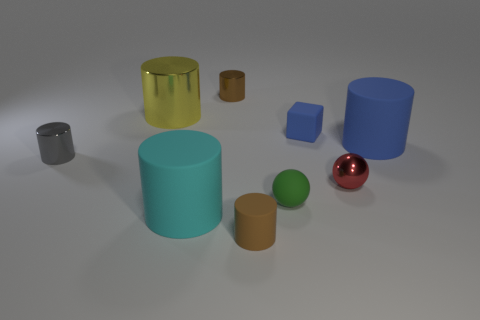There is a yellow object; does it have the same size as the metallic object that is in front of the tiny gray shiny cylinder?
Give a very brief answer. No. There is a tiny brown cylinder behind the large matte object left of the brown metallic cylinder; what is its material?
Keep it short and to the point. Metal. Are there the same number of big things that are behind the big blue rubber thing and blue matte cylinders?
Offer a very short reply. Yes. How big is the metallic object that is behind the tiny blue block and to the right of the big cyan object?
Give a very brief answer. Small. What is the color of the big matte object left of the tiny brown cylinder that is in front of the tiny gray metallic thing?
Your answer should be compact. Cyan. What number of blue things are blocks or big shiny cylinders?
Ensure brevity in your answer.  1. There is a shiny thing that is behind the tiny blue rubber thing and left of the large cyan matte cylinder; what color is it?
Your answer should be compact. Yellow. What number of big things are cyan things or blue matte cylinders?
Provide a succinct answer. 2. The red thing that is the same shape as the green object is what size?
Make the answer very short. Small. The brown shiny thing is what shape?
Your answer should be very brief. Cylinder. 